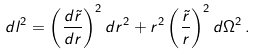<formula> <loc_0><loc_0><loc_500><loc_500>d l ^ { 2 } = \left ( \frac { d \tilde { r } } { d r } \right ) ^ { 2 } d r ^ { 2 } + r ^ { 2 } \left ( \frac { \tilde { r } } { r } \right ) ^ { 2 } d \Omega ^ { 2 } \, .</formula> 